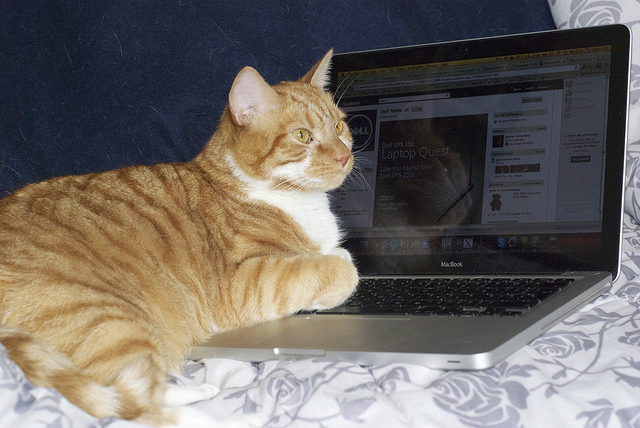<image>What computer logo can be seen on the monitor's screen? It is unclear what computer logo is on the monitor's screen. It could possibly be Dell. What computer logo can be seen on the monitor's screen? I don't know the computer logo that can be seen on the monitor's screen. It can be Dell or Mac. 